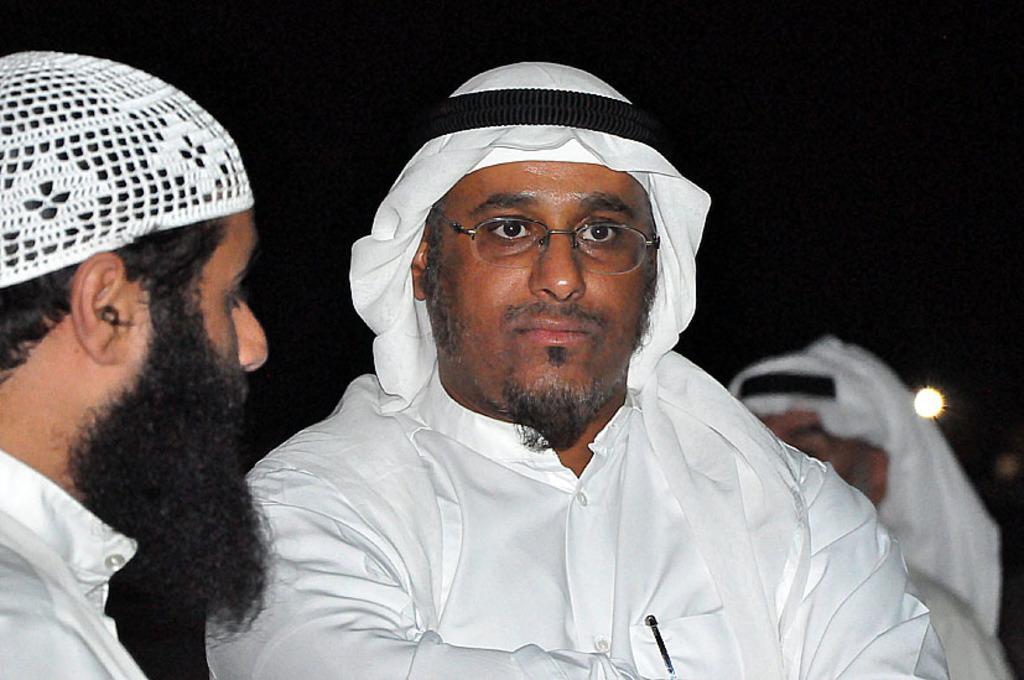How would you summarize this image in a sentence or two? There are people in the foreground and a person and light in the background. 